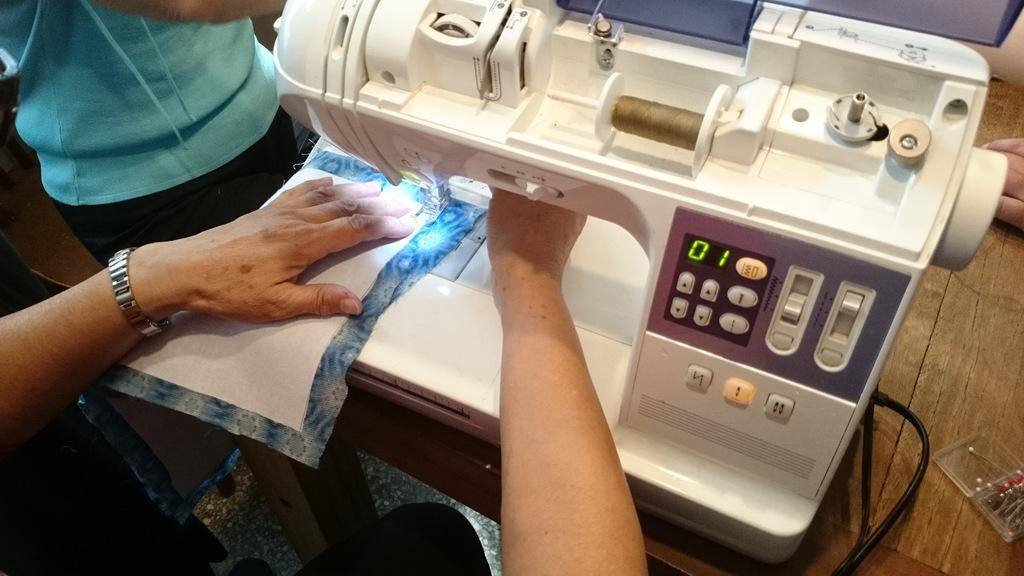Could you give a brief overview of what you see in this image? As we can see in the image there are two people, cloth and table. On table there are sewing machine. 